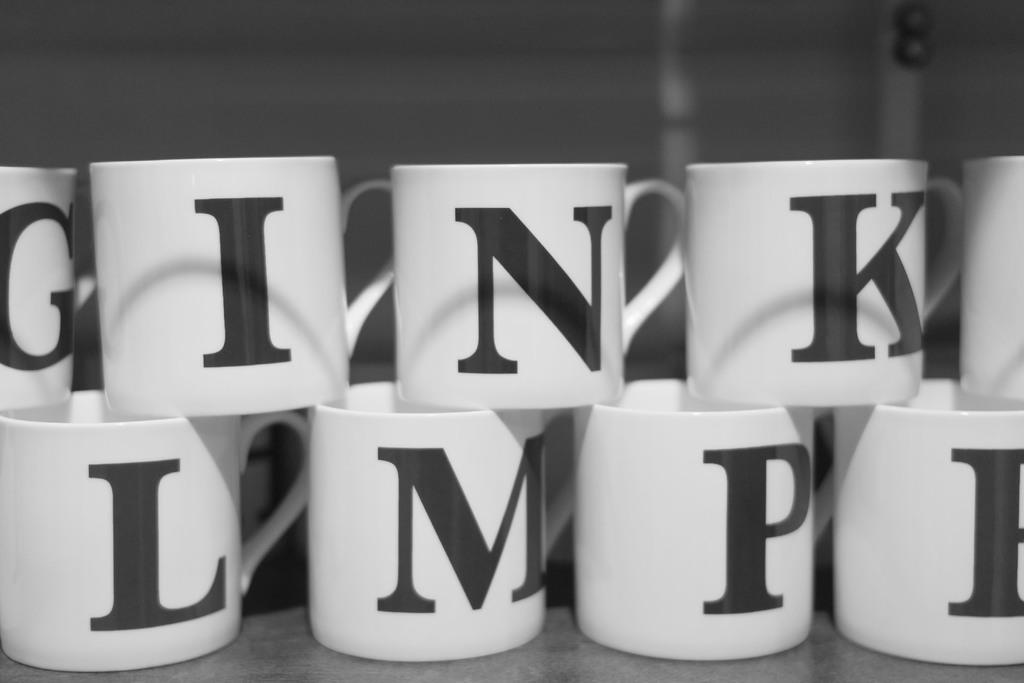<image>
Give a short and clear explanation of the subsequent image. White mugs are stacked together, each bearing a different letter of the alphabet in black. 